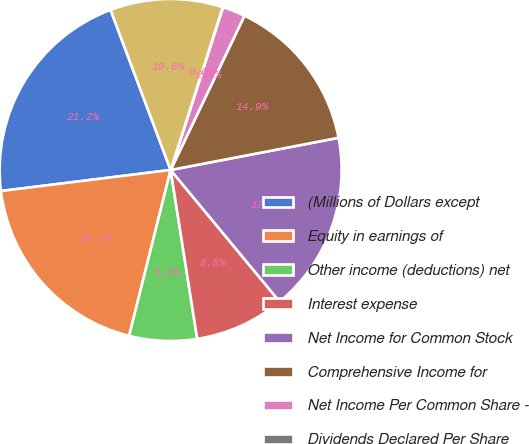Convert chart to OTSL. <chart><loc_0><loc_0><loc_500><loc_500><pie_chart><fcel>(Millions of Dollars except<fcel>Equity in earnings of<fcel>Other income (deductions) net<fcel>Interest expense<fcel>Net Income for Common Stock<fcel>Comprehensive Income for<fcel>Net Income Per Common Share -<fcel>Dividends Declared Per Share<fcel>Average Number Of Shares<nl><fcel>21.25%<fcel>19.13%<fcel>6.39%<fcel>8.52%<fcel>17.01%<fcel>14.88%<fcel>2.15%<fcel>0.03%<fcel>10.64%<nl></chart> 